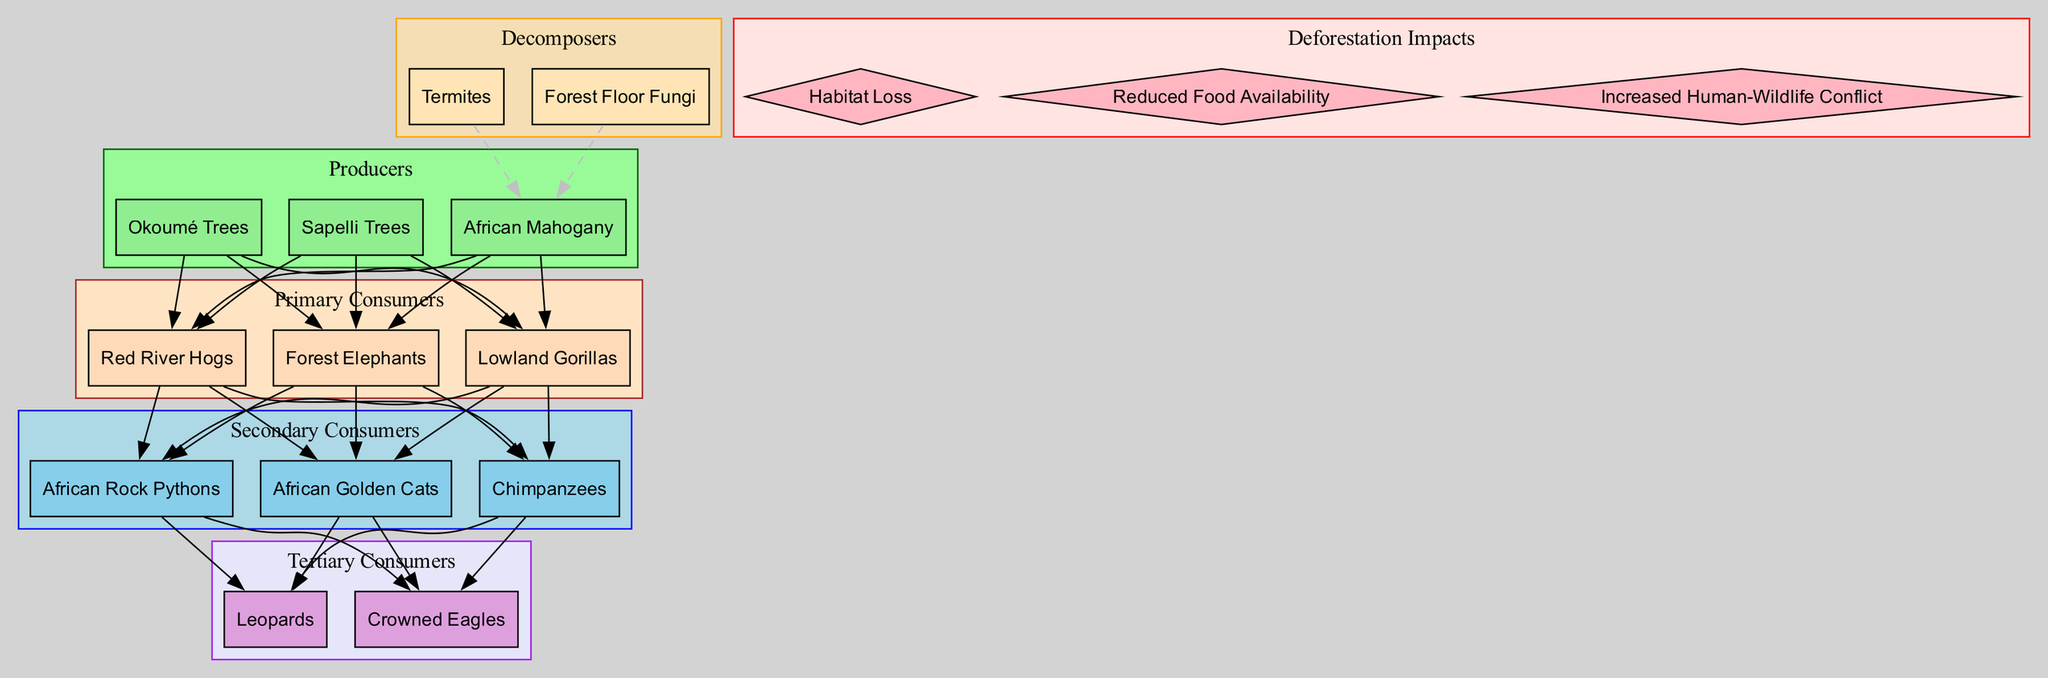What are the primary consumers in this food chain? The primary consumers are listed in the "Primary Consumers" section of the diagram. They include "Forest Elephants," "Lowland Gorillas," and "Red River Hogs."
Answer: Forest Elephants, Lowland Gorillas, Red River Hogs How many producers are there? The producers are represented in the "Producers" section. There are three listed: "African Mahogany," "Okoumé Trees," and "Sapelli Trees." Thus, the count is three.
Answer: 3 Which secondary consumer preys on Lowland Gorillas? By looking at the connections in the diagram, the secondary consumers are "African Golden Cats," "Chimpanzees," and "African Rock Pythons." Since Gorillas are primary consumers, the direct predator is "Chimpanzees."
Answer: Chimpanzees What is a decomposer in this food chain? The decomposers are noted in their respective section of the diagram. They include "Termites" and "Forest Floor Fungi."
Answer: Termites, Forest Floor Fungi Which impact of deforestation is related to the depletion of food sources? The impact directly related to food sources in the diagram is "Reduced Food Availability," specified under the "Deforestation Impacts" section.
Answer: Reduced Food Availability What type of consumers are Leopards? They are classified as tertiary consumers in the diagram, which indicates their position in the food chain as higher-level predators.
Answer: Tertiary consumers How many edges connect producers to primary consumers? Each producer connects to every primary consumer with an edge. Since there are three producers and three primary consumers, the total number of edges is 3 producers x 3 primary consumers = 9 edges.
Answer: 9 Which animal is at the top of the food chain? The "Tertiary Consumers" section specifies that both "Leopards" and "Crowned Eagles" occupy this position as top predators in the food chain.
Answer: Leopards, Crowned Eagles 